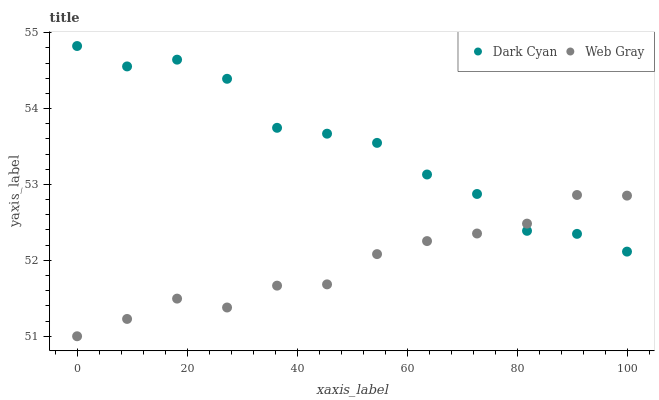Does Web Gray have the minimum area under the curve?
Answer yes or no. Yes. Does Dark Cyan have the maximum area under the curve?
Answer yes or no. Yes. Does Web Gray have the maximum area under the curve?
Answer yes or no. No. Is Web Gray the smoothest?
Answer yes or no. Yes. Is Dark Cyan the roughest?
Answer yes or no. Yes. Is Web Gray the roughest?
Answer yes or no. No. Does Web Gray have the lowest value?
Answer yes or no. Yes. Does Dark Cyan have the highest value?
Answer yes or no. Yes. Does Web Gray have the highest value?
Answer yes or no. No. Does Web Gray intersect Dark Cyan?
Answer yes or no. Yes. Is Web Gray less than Dark Cyan?
Answer yes or no. No. Is Web Gray greater than Dark Cyan?
Answer yes or no. No. 